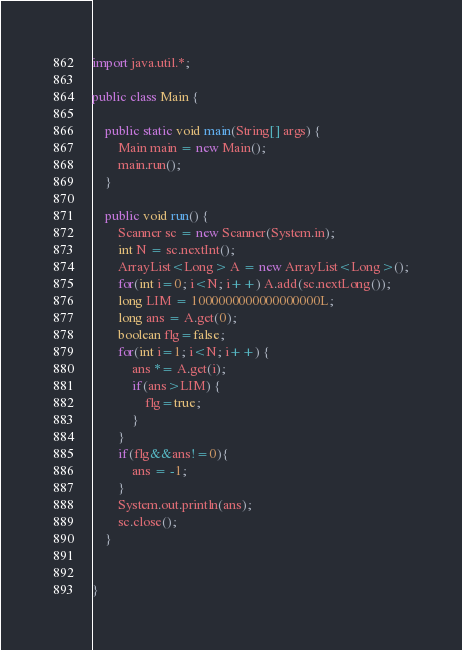Convert code to text. <code><loc_0><loc_0><loc_500><loc_500><_Java_>
import java.util.*;

public class Main {

	public static void main(String[] args) {
		Main main = new Main();
		main.run();
	}

	public void run() {
		Scanner sc = new Scanner(System.in);
		int N = sc.nextInt();
		ArrayList<Long> A = new ArrayList<Long>();
		for(int i=0; i<N; i++) A.add(sc.nextLong());
		long LIM = 1000000000000000000L;
		long ans = A.get(0);
		boolean flg=false;
		for(int i=1; i<N; i++) {
			ans *= A.get(i);
			if(ans>LIM) {
				flg=true;
			}
		}
		if(flg&&ans!=0){
			ans = -1;
		}
		System.out.println(ans);
		sc.close();
	}


}</code> 